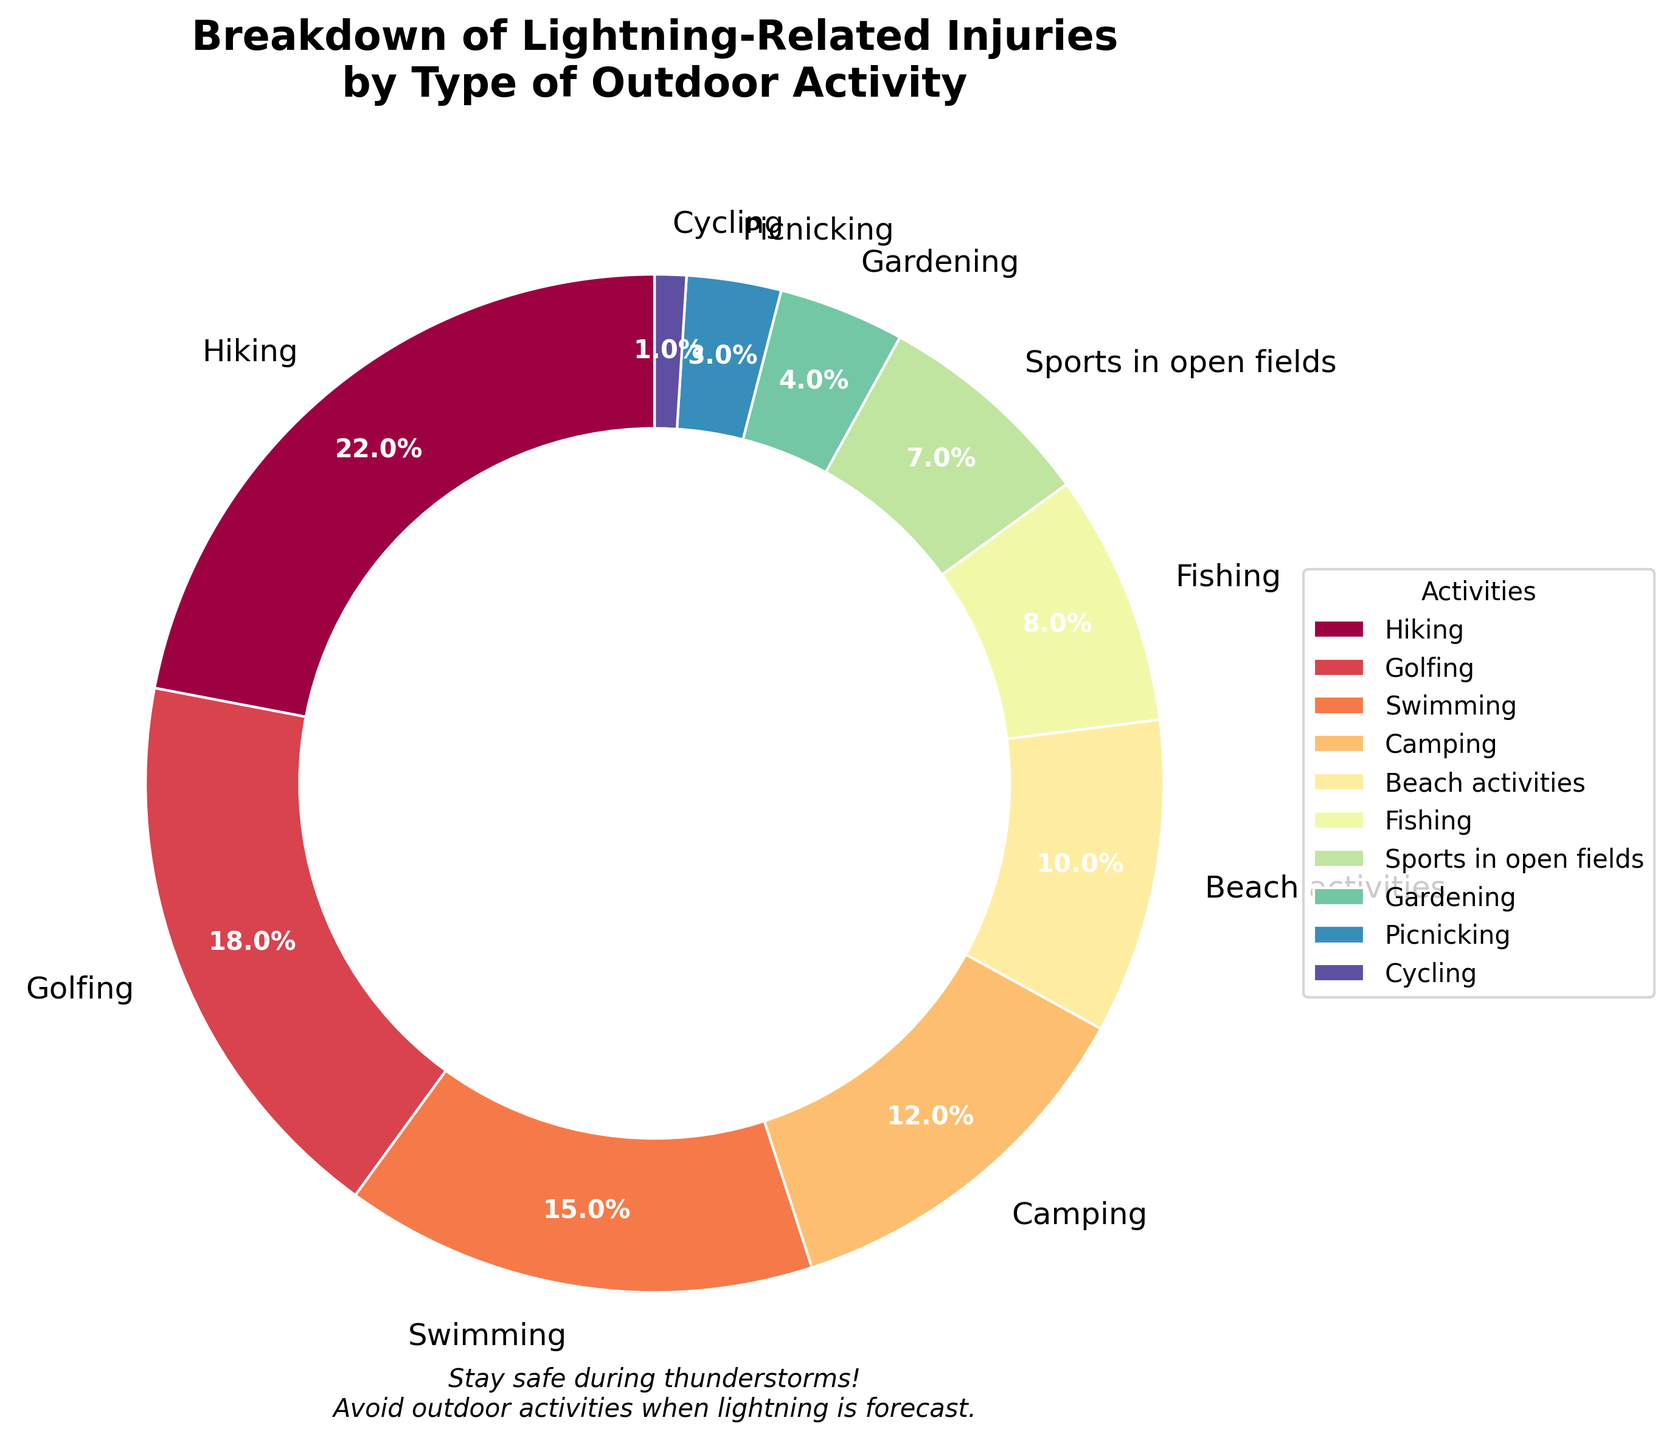What activity has the highest percentage of lightning-related injuries? The activity with the highest percentage can be identified by the largest segment in the pie chart. "Hiking" has the largest segment at 22%.
Answer: Hiking Which three activities together account for more than 50% of lightning-related injuries? Add the percentages of the top three activities: Hiking (22%), Golfing (18%), and Swimming (15%). The total is 22 + 18 + 15 = 55%, which is more than half.
Answer: Hiking, Golfing, and Swimming What is the combined percentage of injuries from Camping and Fishing? Find the percentages for Camping (12%) and Fishing (8%) and add them together: 12 + 8 = 20%.
Answer: 20% Are there more injuries related to Golfing or Swimming? Compare the percentages for Golfing (18%) and Swimming (15%). Golfing has a higher percentage.
Answer: Golfing Which activity has the smallest percentage of lightning-related injuries and what is the percentage? Identify the smallest segment in the pie chart, which represents "Cycling" with 1%.
Answer: Cycling, 1% How many activities account for less than 10% of injuries each? Count the activities with percentages less than 10%: Fishing (8%), Sports in open fields (7%), Gardening (4%), Picnicking (3%), and Cycling (1%). There are five such activities.
Answer: 5 Is the percentage of injuries from Beach activities greater than that from Camping? Compare the percentages for Beach activities (10%) and Camping (12%). Beach activities have a lower percentage.
Answer: No Which activities have nearly the same percentage of injuries? Find activities with percentages close to each other. Golfing (18%) and Swimming (15%) have percentages that are close compared to the others.
Answer: Golfing and Swimming 